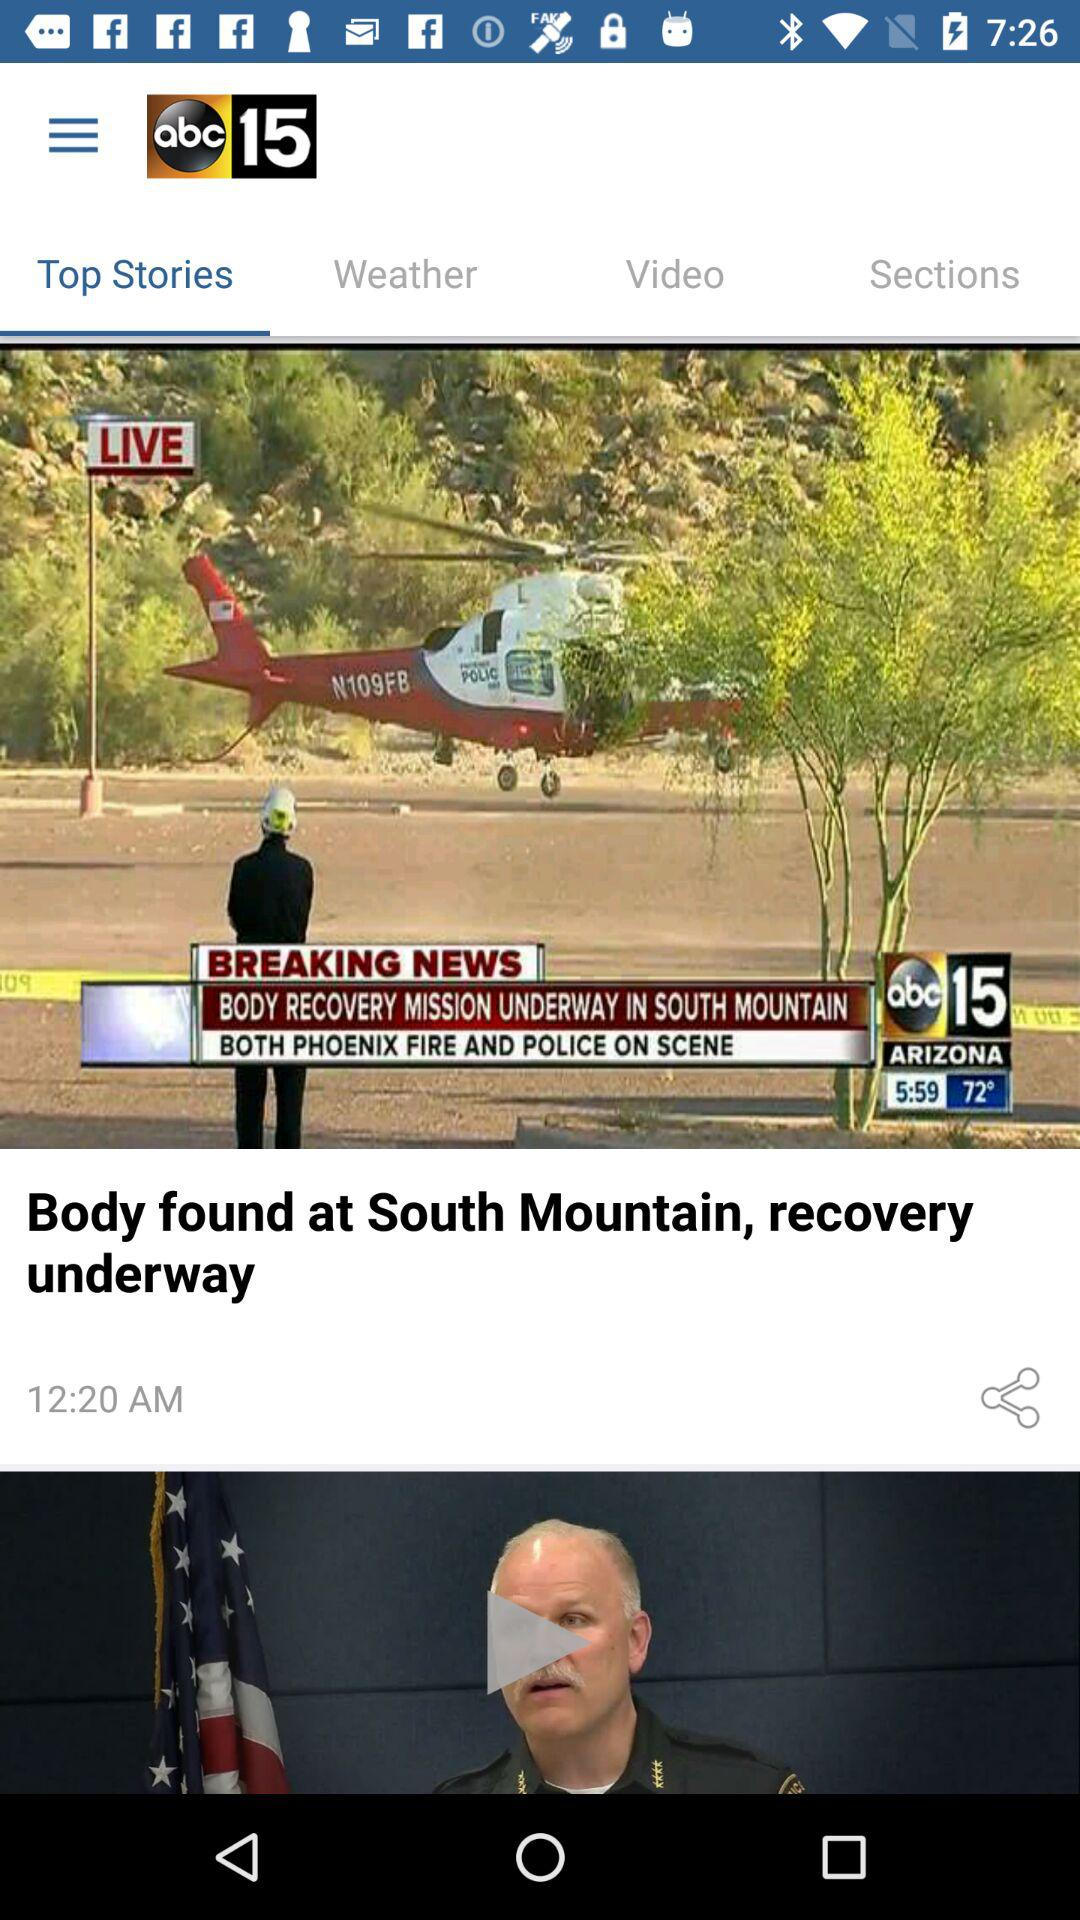What is the shown time? The shown times are 5:59 and 12:20 AM. 